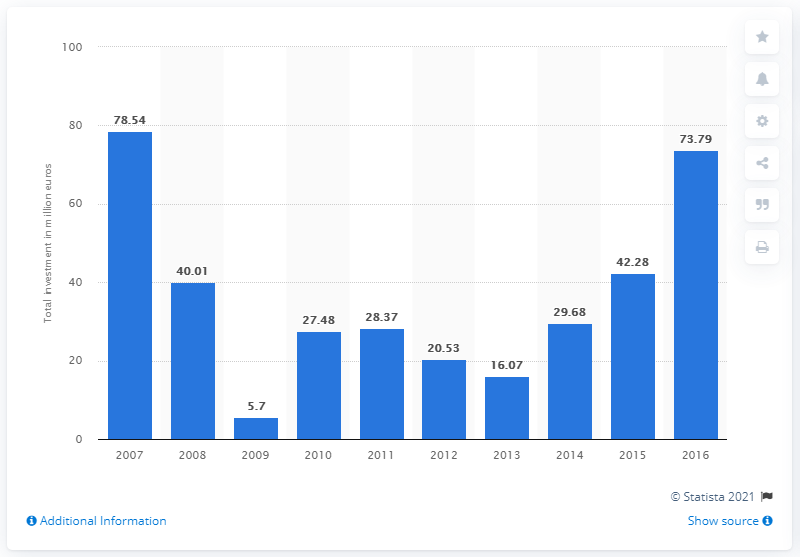Point out several critical features in this image. In 2007, the largest total value of private equity investments was recorded. As of 2016, the value of private equity investments was 73.79.. 